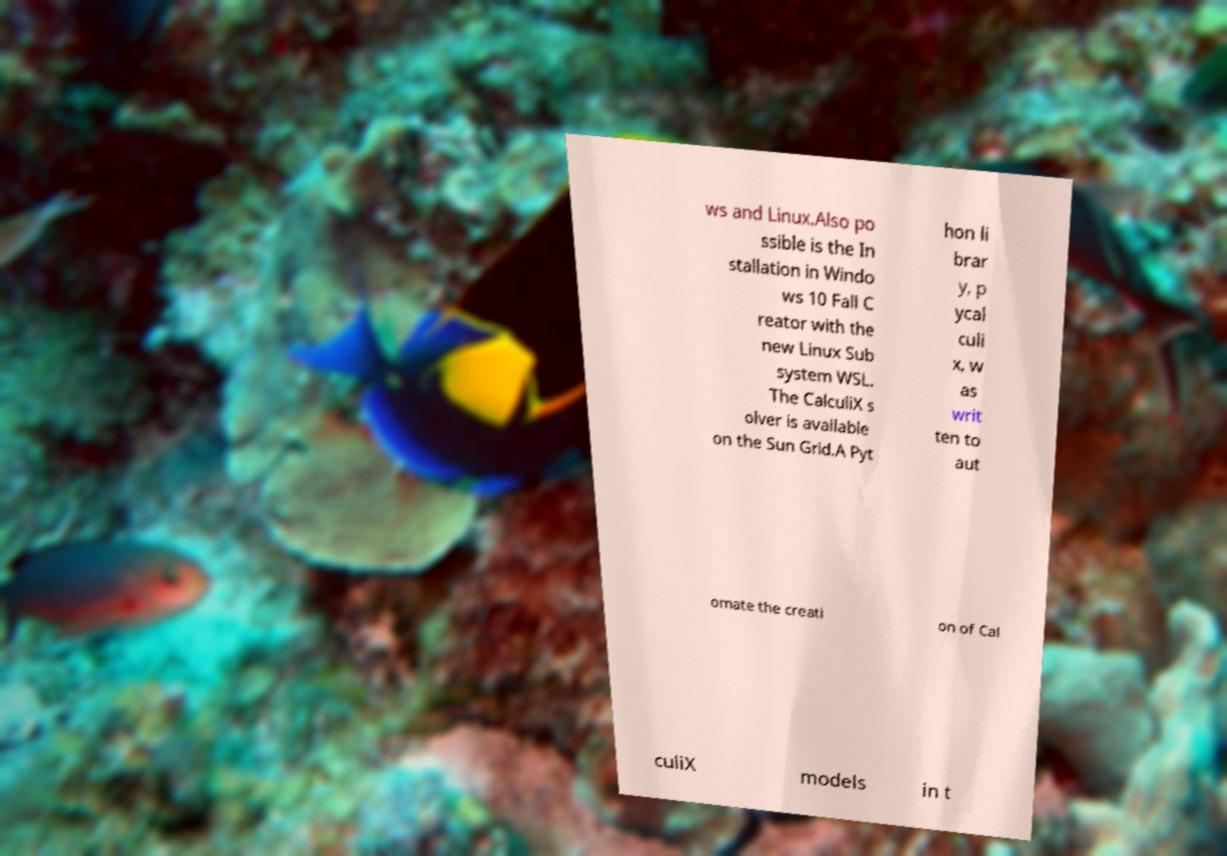For documentation purposes, I need the text within this image transcribed. Could you provide that? ws and Linux.Also po ssible is the In stallation in Windo ws 10 Fall C reator with the new Linux Sub system WSL. The CalculiX s olver is available on the Sun Grid.A Pyt hon li brar y, p ycal culi x, w as writ ten to aut omate the creati on of Cal culiX models in t 